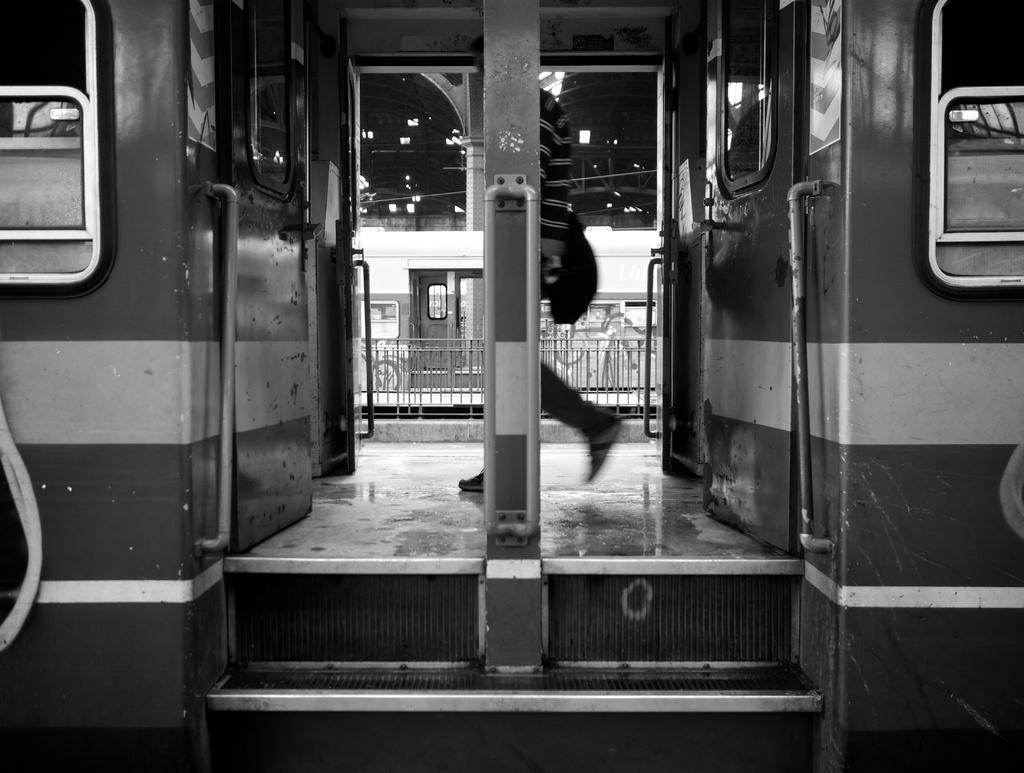Can you describe this image briefly? This is a black and white image. It looks like a coach. I can see a person is walking in the coach. In the background, there is another coach, roof, pillar and iron grilles. 